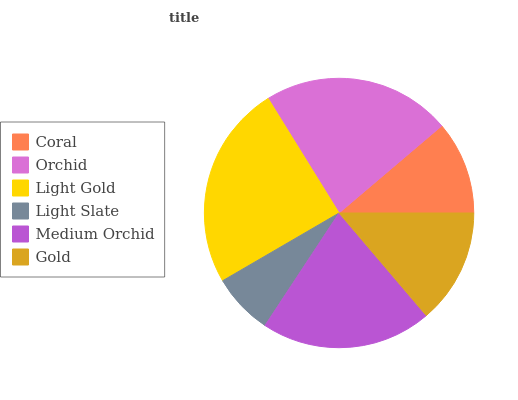Is Light Slate the minimum?
Answer yes or no. Yes. Is Light Gold the maximum?
Answer yes or no. Yes. Is Orchid the minimum?
Answer yes or no. No. Is Orchid the maximum?
Answer yes or no. No. Is Orchid greater than Coral?
Answer yes or no. Yes. Is Coral less than Orchid?
Answer yes or no. Yes. Is Coral greater than Orchid?
Answer yes or no. No. Is Orchid less than Coral?
Answer yes or no. No. Is Medium Orchid the high median?
Answer yes or no. Yes. Is Gold the low median?
Answer yes or no. Yes. Is Light Slate the high median?
Answer yes or no. No. Is Light Slate the low median?
Answer yes or no. No. 